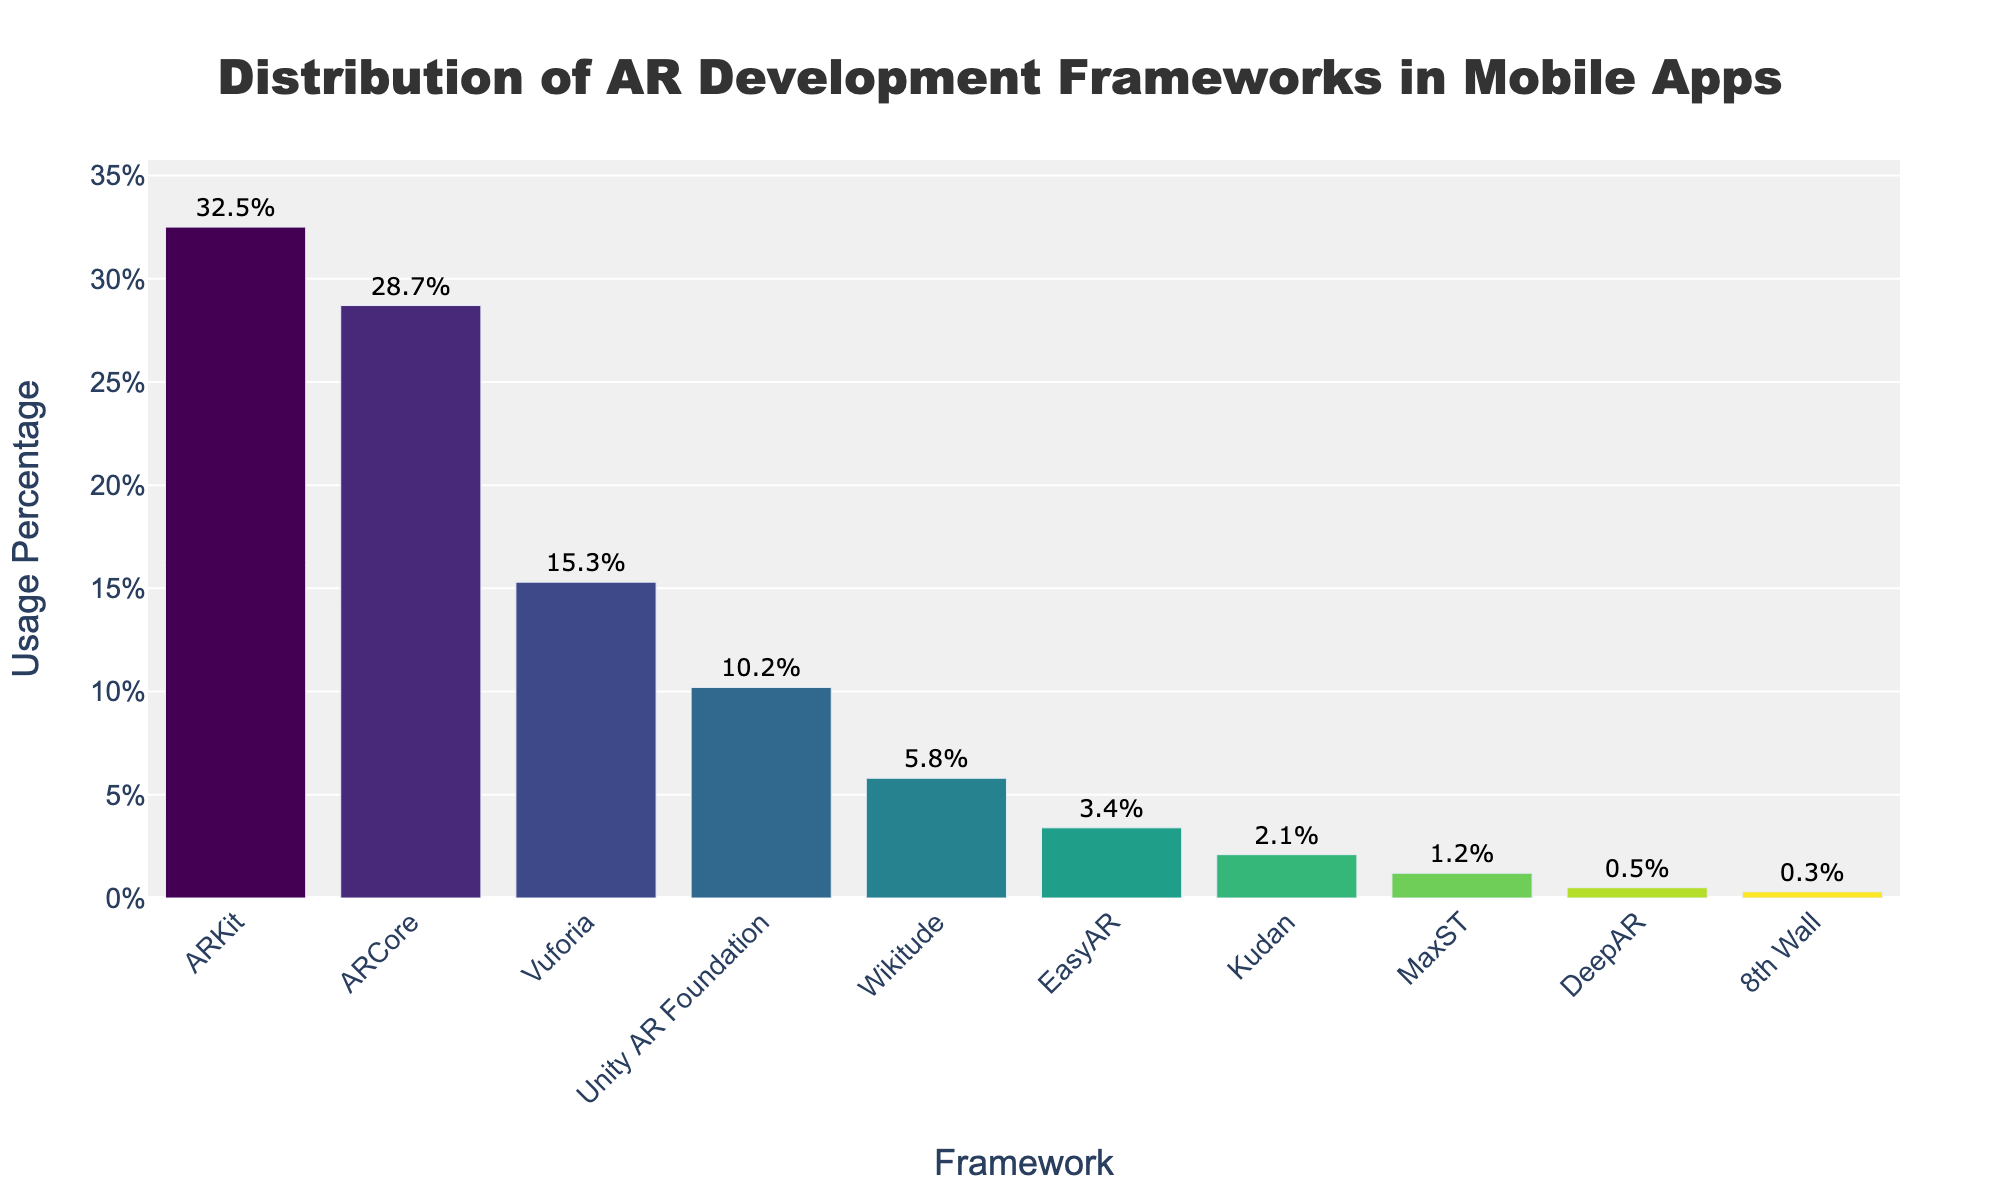What's the most used AR development framework in mobile apps? The highest bar represents the most used framework. From the figure, ARKit has the highest percentage.
Answer: ARKit Which framework has a slightly higher usage percentage than Unity AR Foundation? Identify the bar that is slightly higher than Unity AR Foundation's bar. ARCore is slightly higher.
Answer: ARCore What's the difference in usage percentage between ARKit and 8th Wall? Subtract the usage percentage of 8th Wall from ARKit. \( 32.5\% - 0.3\% = 32.2\% \).
Answer: 32.2% How many frameworks have a usage percentage above 10%? Count the bars taller than 10% on the y-axis. ARKit, ARCore, Vuforia, and Unity AR Foundation meet this criterion.
Answer: 4 Which frameworks are used less than 5% in mobile apps? Identify the frameworks whose bars are below the 5% mark. EasyAR, Kudan, MaxST, DeepAR, and 8th Wall fit this requirement.
Answer: EasyAR, Kudan, MaxST, DeepAR, 8th Wall What's the sum of the usage percentages for Vuforia, Wikitude, and EasyAR? Add the usage percentages of these three frameworks: \( 15.3\% + 5.8\% + 3.4\% = 24.5\% \).
Answer: 24.5% Which framework has the third-highest usage percentage? Sort the frameworks by height and identify the third one. Vuforia is the third highest.
Answer: Vuforia By how much does the usage percentage of Unity AR Foundation exceed that of Kudan? Subtract the usage percentage of Kudan from Unity AR Foundation: \( 10.2\% - 2.1\% = 8.1\% \).
Answer: 8.1% What is the range of usage percentages in the dataset? Subtract the smallest usage percentage from the largest: \( 32.5\% - 0.3\% = 32.2\% \).
Answer: 32.2% Are there more frameworks with a usage percentage below or above 5%? Count the bars below and above 5%. Below 5%: EasyAR, Kudan, MaxST, DeepAR, 8th Wall (5 frameworks). Above 5%: ARKit, ARCore, Vuforia, Unity AR Foundation, Wikitude (5 frameworks). The counts are equal.
Answer: Equal 